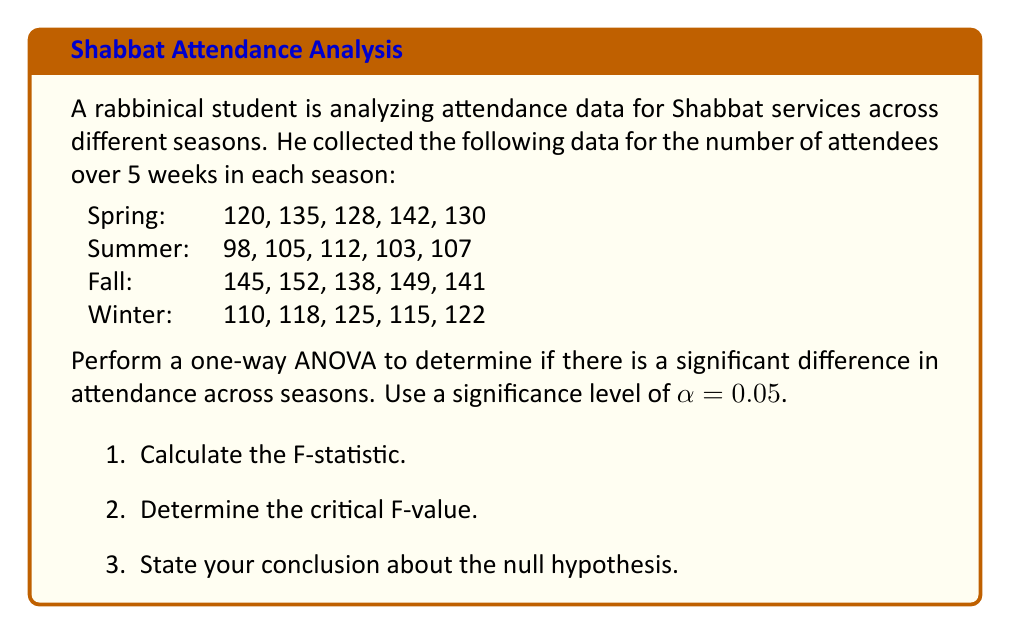Show me your answer to this math problem. Let's approach this step-by-step:

1. First, we need to calculate the sum of squares between groups (SSB) and within groups (SSW).

2. Calculate the mean for each season and the grand mean:
   Spring mean: $\bar{x}_1 = 131$
   Summer mean: $\bar{x}_2 = 105$
   Fall mean: $\bar{x}_3 = 145$
   Winter mean: $\bar{x}_4 = 118$
   Grand mean: $\bar{x} = 124.75$

3. Calculate SSB:
   $$SSB = 5[(131-124.75)^2 + (105-124.75)^2 + (145-124.75)^2 + (118-124.75)^2] = 5962.75$$

4. Calculate SSW:
   $$SSW = \sum_{i=1}^{4}\sum_{j=1}^{5}(x_{ij}-\bar{x}_i)^2 = 1097$$

5. Calculate degrees of freedom:
   Between groups: $df_B = 4 - 1 = 3$
   Within groups: $df_W = 20 - 4 = 16$

6. Calculate Mean Square Between (MSB) and Mean Square Within (MSW):
   $$MSB = SSB / df_B = 5962.75 / 3 = 1987.58$$
   $$MSW = SSW / df_W = 1097 / 16 = 68.56$$

7. Calculate F-statistic:
   $$F = MSB / MSW = 1987.58 / 68.56 = 29.00$$

8. Find the critical F-value:
   For $\alpha = 0.05$, $df_B = 3$, and $df_W = 16$, the critical F-value is approximately 3.24.

9. Compare F-statistic to critical F-value:
   Since $29.00 > 3.24$, we reject the null hypothesis.
Answer: 1. F-statistic: 29.00
2. Critical F-value: 3.24
3. Conclusion: Reject the null hypothesis. There is significant evidence to suggest that attendance at Shabbat services differs across seasons. 